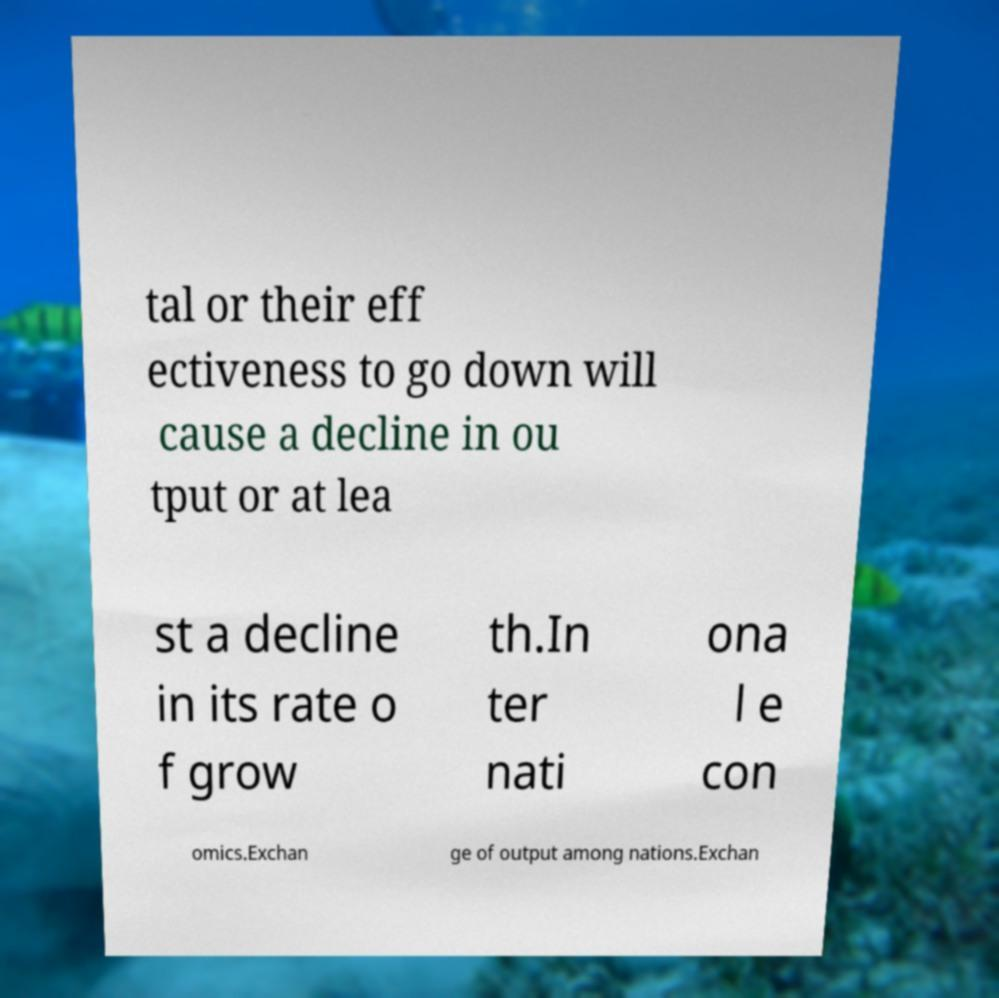Can you accurately transcribe the text from the provided image for me? tal or their eff ectiveness to go down will cause a decline in ou tput or at lea st a decline in its rate o f grow th.In ter nati ona l e con omics.Exchan ge of output among nations.Exchan 